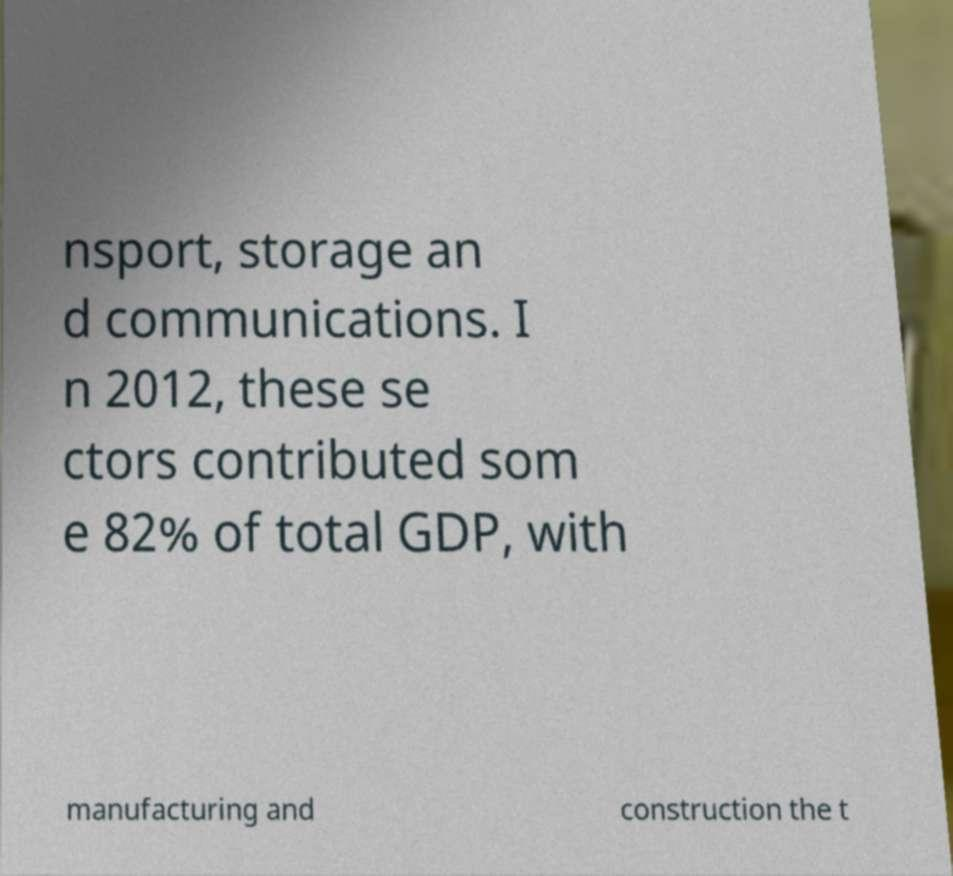There's text embedded in this image that I need extracted. Can you transcribe it verbatim? nsport, storage an d communications. I n 2012, these se ctors contributed som e 82% of total GDP, with manufacturing and construction the t 